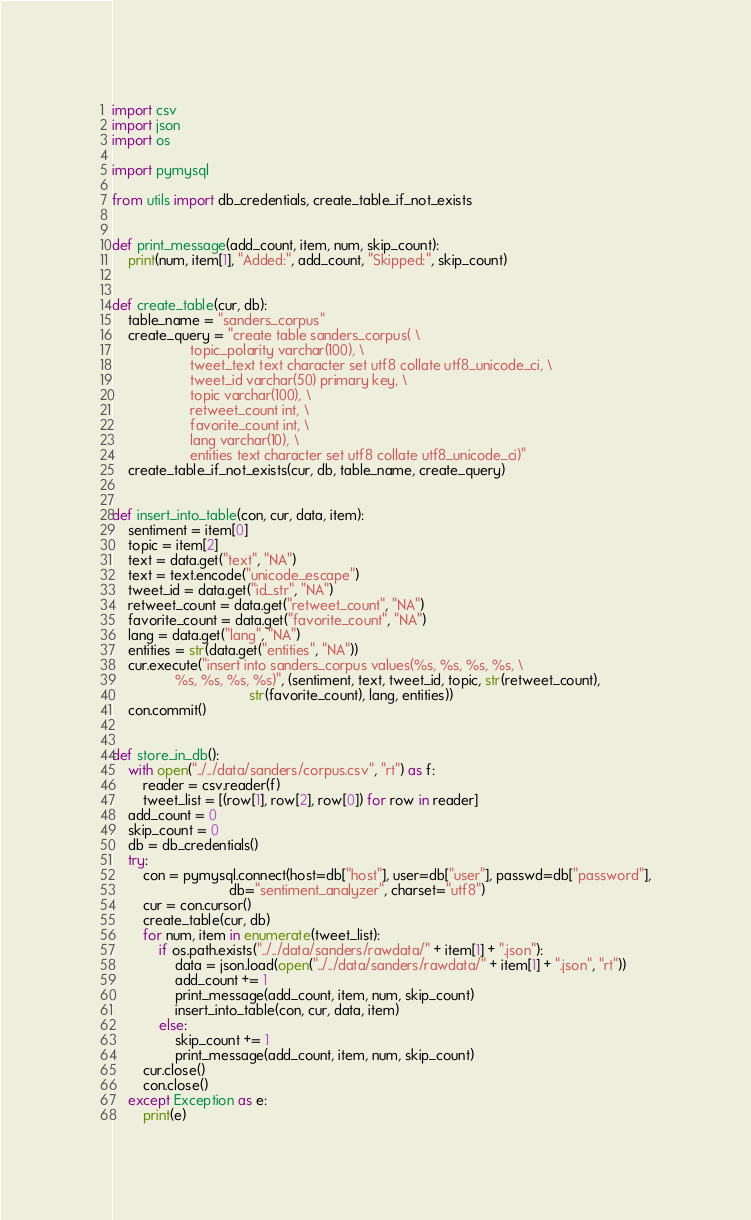<code> <loc_0><loc_0><loc_500><loc_500><_Python_>import csv
import json
import os

import pymysql

from utils import db_credentials, create_table_if_not_exists


def print_message(add_count, item, num, skip_count):
    print(num, item[1], "Added:", add_count, "Skipped:", skip_count)


def create_table(cur, db):
    table_name = "sanders_corpus"
    create_query = "create table sanders_corpus( \
                    topic_polarity varchar(100), \
                    tweet_text text character set utf8 collate utf8_unicode_ci, \
                    tweet_id varchar(50) primary key, \
                    topic varchar(100), \
                    retweet_count int, \
                    favorite_count int, \
                    lang varchar(10), \
                    entities text character set utf8 collate utf8_unicode_ci)"
    create_table_if_not_exists(cur, db, table_name, create_query)


def insert_into_table(con, cur, data, item):
    sentiment = item[0]
    topic = item[2]
    text = data.get("text", "NA")
    text = text.encode("unicode_escape")
    tweet_id = data.get("id_str", "NA")
    retweet_count = data.get("retweet_count", "NA")
    favorite_count = data.get("favorite_count", "NA")
    lang = data.get("lang", "NA")
    entities = str(data.get("entities", "NA"))
    cur.execute("insert into sanders_corpus values(%s, %s, %s, %s, \
                %s, %s, %s, %s)", (sentiment, text, tweet_id, topic, str(retweet_count),
                                   str(favorite_count), lang, entities))
    con.commit()


def store_in_db():
    with open("../../data/sanders/corpus.csv", "rt") as f:
        reader = csv.reader(f)
        tweet_list = [(row[1], row[2], row[0]) for row in reader]
    add_count = 0
    skip_count = 0
    db = db_credentials()
    try:
        con = pymysql.connect(host=db["host"], user=db["user"], passwd=db["password"],
                              db="sentiment_analyzer", charset="utf8")
        cur = con.cursor()
        create_table(cur, db)
        for num, item in enumerate(tweet_list):
            if os.path.exists("../../data/sanders/rawdata/" + item[1] + ".json"):
                data = json.load(open("../../data/sanders/rawdata/" + item[1] + ".json", "rt"))
                add_count += 1
                print_message(add_count, item, num, skip_count)
                insert_into_table(con, cur, data, item)
            else:
                skip_count += 1
                print_message(add_count, item, num, skip_count)
        cur.close()
        con.close()
    except Exception as e:
        print(e)
</code> 